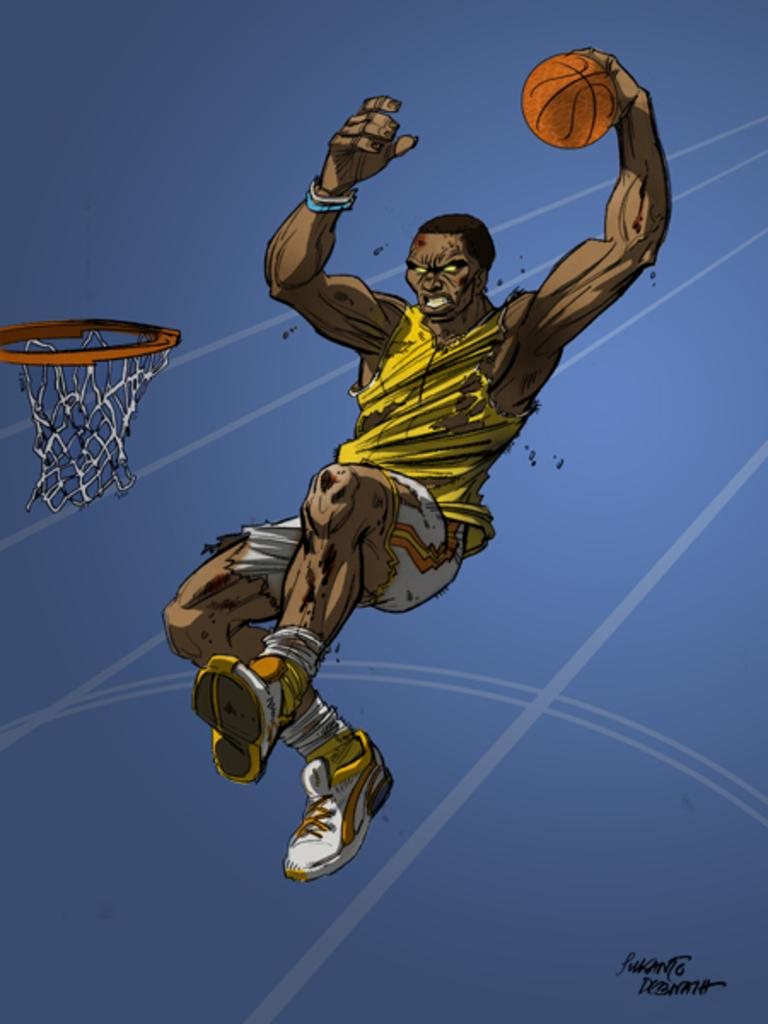What is the main subject of the image? There is an art piece in the image. What does the art piece depict? The art piece depicts a person playing basketball. How many words are written on the basketball in the image? There are no words written on the basketball in the image. How long does it take for the person to complete a minute of playing basketball in the image? The image is a static representation and does not depict the passage of time, so it is impossible to determine how long it takes for the person to complete a minute of playing basketball. 